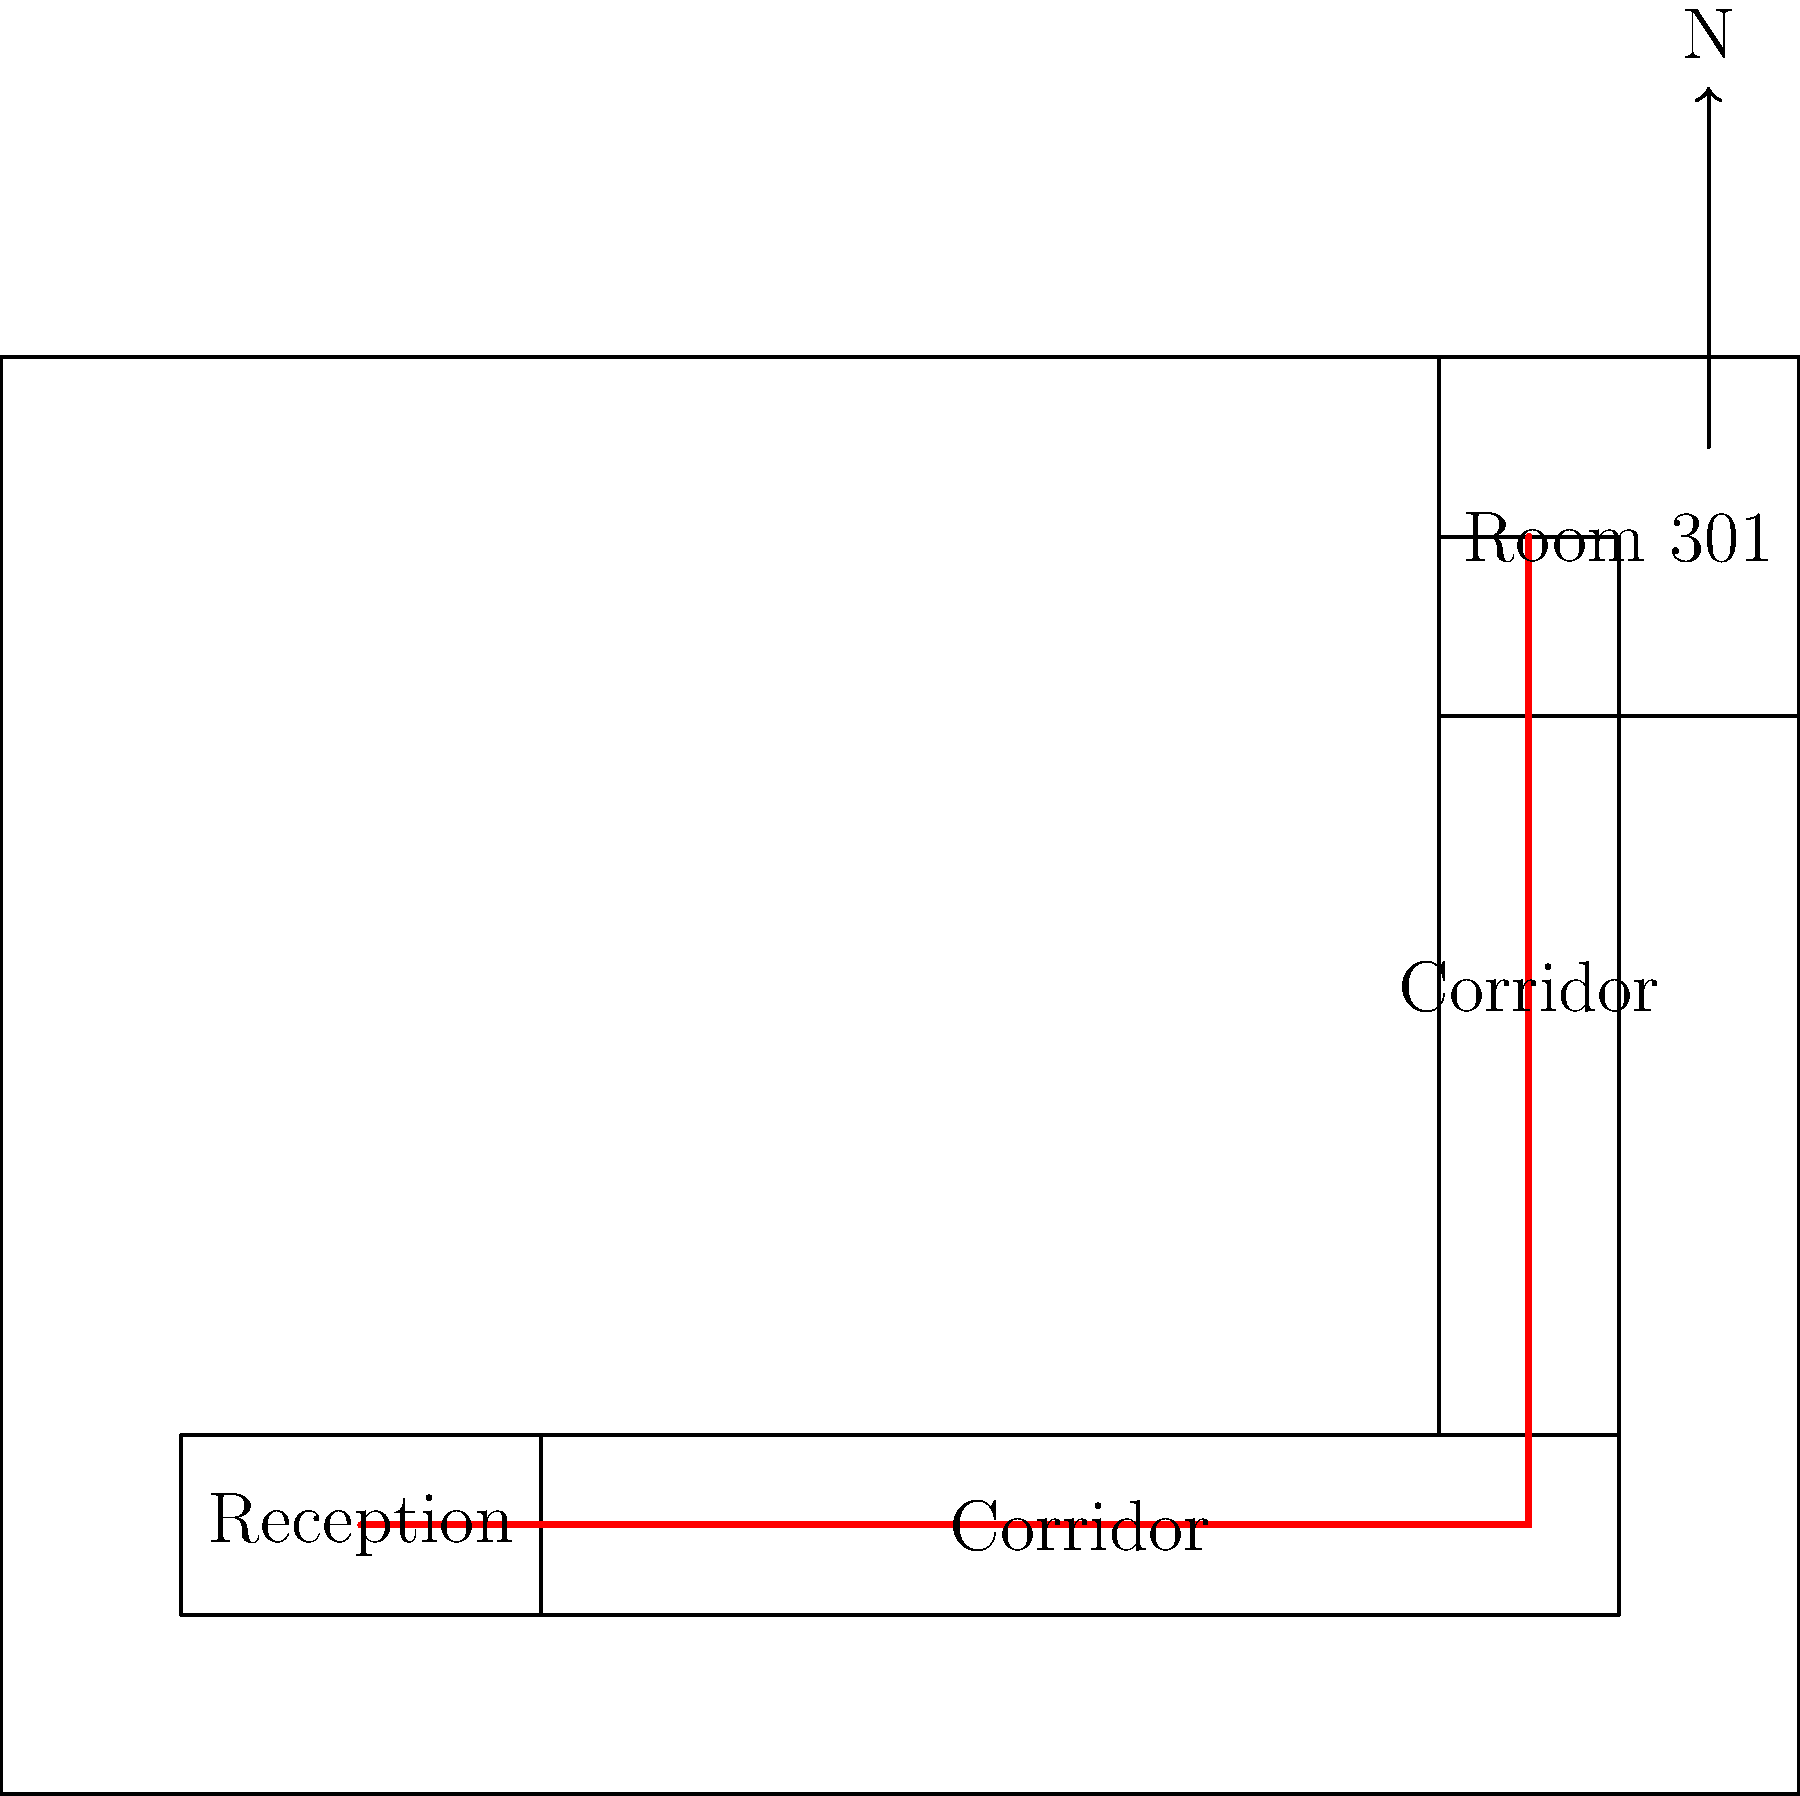As a receptionist, you need to guide a guest to Room 301. Based on the floor plan, what is the quickest route from the reception desk to Room 301? Describe the path in terms of directions and corridors. To determine the quickest route from the reception desk to Room 301, we need to analyze the floor plan:

1. Start at the reception desk, located in the bottom-left corner of the floor plan.
2. Exit the reception area and turn right into the main corridor running along the bottom of the floor plan.
3. Follow this corridor eastward (to the right on the plan) until you reach the junction with the vertical corridor on the right side of the floor plan.
4. Turn left (north) into this vertical corridor.
5. Follow the vertical corridor upwards (northward) until you reach Room 301, which is located in the top-right corner of the floor plan.

This route utilizes the two main corridors and involves only one turn, making it the most direct and quickest path from the reception to Room 301.
Answer: Exit reception, right along bottom corridor, left up side corridor to Room 301. 